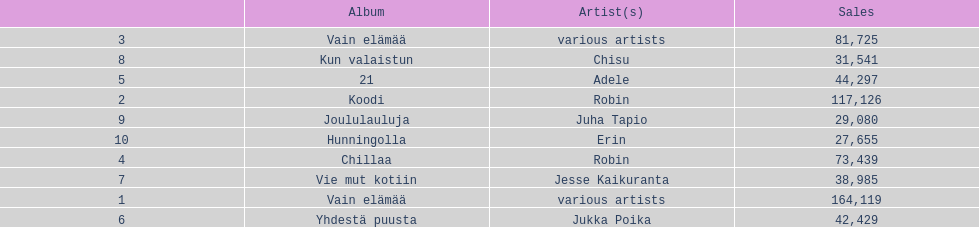Which album had the least amount of sales? Hunningolla. 